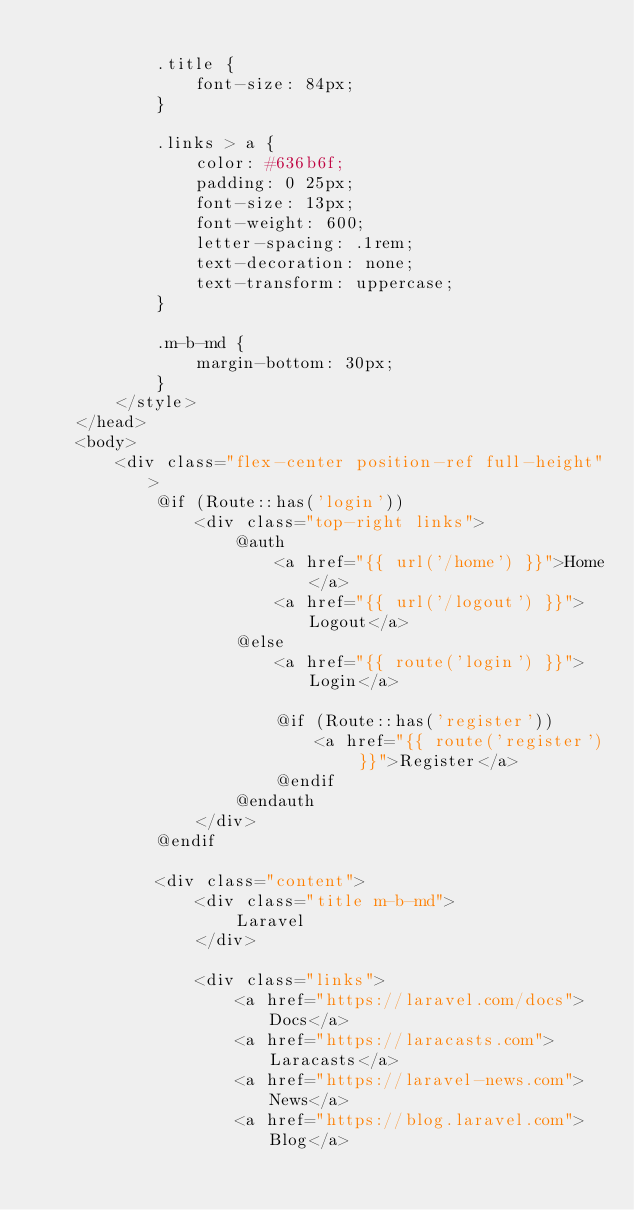<code> <loc_0><loc_0><loc_500><loc_500><_PHP_>
            .title {
                font-size: 84px;
            }

            .links > a {
                color: #636b6f;
                padding: 0 25px;
                font-size: 13px;
                font-weight: 600;
                letter-spacing: .1rem;
                text-decoration: none;
                text-transform: uppercase;
            }

            .m-b-md {
                margin-bottom: 30px;
            }
        </style>
    </head>
    <body>
        <div class="flex-center position-ref full-height">
            @if (Route::has('login'))
                <div class="top-right links">
                    @auth
                        <a href="{{ url('/home') }}">Home</a>
                        <a href="{{ url('/logout') }}">Logout</a>
                    @else
                        <a href="{{ route('login') }}">Login</a>

                        @if (Route::has('register'))
                            <a href="{{ route('register') }}">Register</a>
                        @endif
                    @endauth
                </div>
            @endif

            <div class="content">
                <div class="title m-b-md">
                    Laravel
                </div>

                <div class="links">
                    <a href="https://laravel.com/docs">Docs</a>
                    <a href="https://laracasts.com">Laracasts</a>
                    <a href="https://laravel-news.com">News</a>
                    <a href="https://blog.laravel.com">Blog</a></code> 